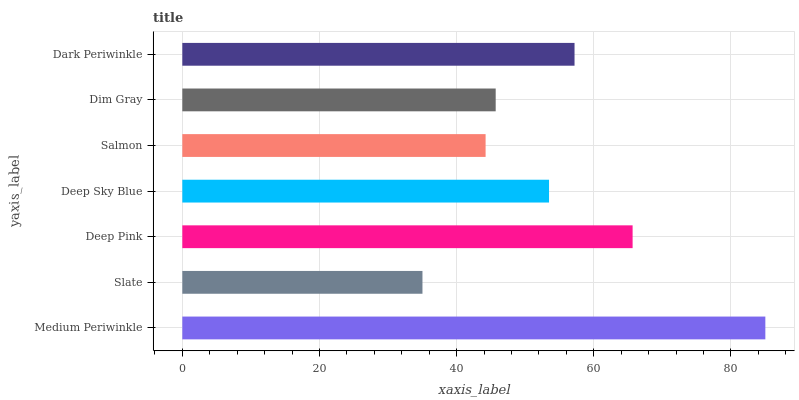Is Slate the minimum?
Answer yes or no. Yes. Is Medium Periwinkle the maximum?
Answer yes or no. Yes. Is Deep Pink the minimum?
Answer yes or no. No. Is Deep Pink the maximum?
Answer yes or no. No. Is Deep Pink greater than Slate?
Answer yes or no. Yes. Is Slate less than Deep Pink?
Answer yes or no. Yes. Is Slate greater than Deep Pink?
Answer yes or no. No. Is Deep Pink less than Slate?
Answer yes or no. No. Is Deep Sky Blue the high median?
Answer yes or no. Yes. Is Deep Sky Blue the low median?
Answer yes or no. Yes. Is Dim Gray the high median?
Answer yes or no. No. Is Dark Periwinkle the low median?
Answer yes or no. No. 